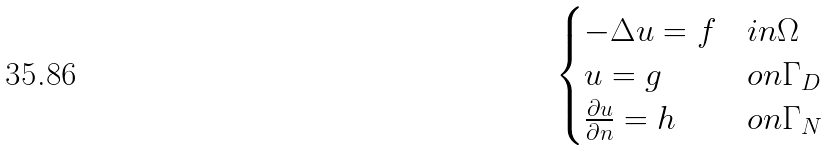Convert formula to latex. <formula><loc_0><loc_0><loc_500><loc_500>\begin{cases} - \Delta u = f & i n \Omega \\ u = g & o n \Gamma _ { D } \\ \frac { \partial u } { \partial n } = h & o n \Gamma _ { N } \end{cases}</formula> 